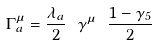<formula> <loc_0><loc_0><loc_500><loc_500>\Gamma ^ { \mu } _ { a } = \frac { \lambda _ { a } } { 2 } \ \gamma ^ { \mu } \ \frac { 1 - \gamma _ { 5 } } { 2 }</formula> 